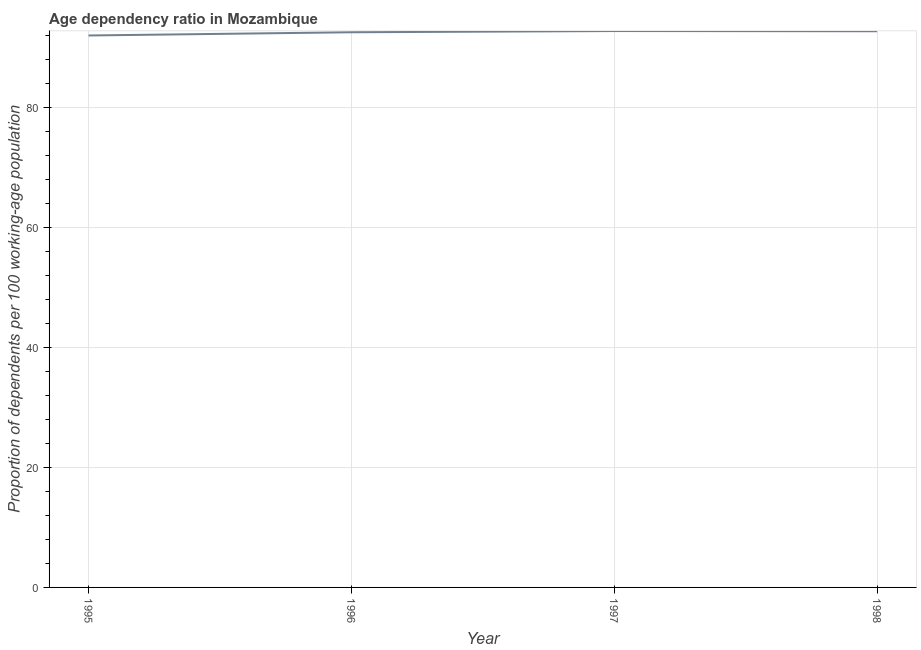What is the age dependency ratio in 1996?
Make the answer very short. 92.49. Across all years, what is the maximum age dependency ratio?
Provide a short and direct response. 92.7. Across all years, what is the minimum age dependency ratio?
Give a very brief answer. 91.96. In which year was the age dependency ratio maximum?
Offer a terse response. 1997. In which year was the age dependency ratio minimum?
Keep it short and to the point. 1995. What is the sum of the age dependency ratio?
Make the answer very short. 369.82. What is the difference between the age dependency ratio in 1995 and 1998?
Your response must be concise. -0.7. What is the average age dependency ratio per year?
Your answer should be very brief. 92.45. What is the median age dependency ratio?
Offer a terse response. 92.58. In how many years, is the age dependency ratio greater than 36 ?
Your answer should be compact. 4. What is the ratio of the age dependency ratio in 1995 to that in 1998?
Your answer should be very brief. 0.99. What is the difference between the highest and the second highest age dependency ratio?
Give a very brief answer. 0.03. What is the difference between the highest and the lowest age dependency ratio?
Keep it short and to the point. 0.74. Does the age dependency ratio monotonically increase over the years?
Your answer should be compact. No. How many lines are there?
Keep it short and to the point. 1. How many years are there in the graph?
Provide a short and direct response. 4. Does the graph contain grids?
Keep it short and to the point. Yes. What is the title of the graph?
Provide a succinct answer. Age dependency ratio in Mozambique. What is the label or title of the Y-axis?
Give a very brief answer. Proportion of dependents per 100 working-age population. What is the Proportion of dependents per 100 working-age population in 1995?
Keep it short and to the point. 91.96. What is the Proportion of dependents per 100 working-age population of 1996?
Keep it short and to the point. 92.49. What is the Proportion of dependents per 100 working-age population of 1997?
Your answer should be compact. 92.7. What is the Proportion of dependents per 100 working-age population in 1998?
Keep it short and to the point. 92.66. What is the difference between the Proportion of dependents per 100 working-age population in 1995 and 1996?
Provide a succinct answer. -0.53. What is the difference between the Proportion of dependents per 100 working-age population in 1995 and 1997?
Your answer should be compact. -0.74. What is the difference between the Proportion of dependents per 100 working-age population in 1995 and 1998?
Give a very brief answer. -0.7. What is the difference between the Proportion of dependents per 100 working-age population in 1996 and 1997?
Your answer should be very brief. -0.2. What is the difference between the Proportion of dependents per 100 working-age population in 1996 and 1998?
Make the answer very short. -0.17. What is the difference between the Proportion of dependents per 100 working-age population in 1997 and 1998?
Provide a succinct answer. 0.03. What is the ratio of the Proportion of dependents per 100 working-age population in 1995 to that in 1996?
Give a very brief answer. 0.99. What is the ratio of the Proportion of dependents per 100 working-age population in 1995 to that in 1998?
Keep it short and to the point. 0.99. What is the ratio of the Proportion of dependents per 100 working-age population in 1996 to that in 1998?
Make the answer very short. 1. What is the ratio of the Proportion of dependents per 100 working-age population in 1997 to that in 1998?
Your answer should be very brief. 1. 